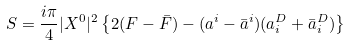<formula> <loc_0><loc_0><loc_500><loc_500>S = \frac { i \pi } { 4 } | X ^ { 0 } | ^ { 2 } \left \{ 2 ( F - \bar { F } ) - ( a ^ { i } - \bar { a } ^ { i } ) ( a _ { i } ^ { D } + \bar { a } _ { i } ^ { D } ) \right \}</formula> 